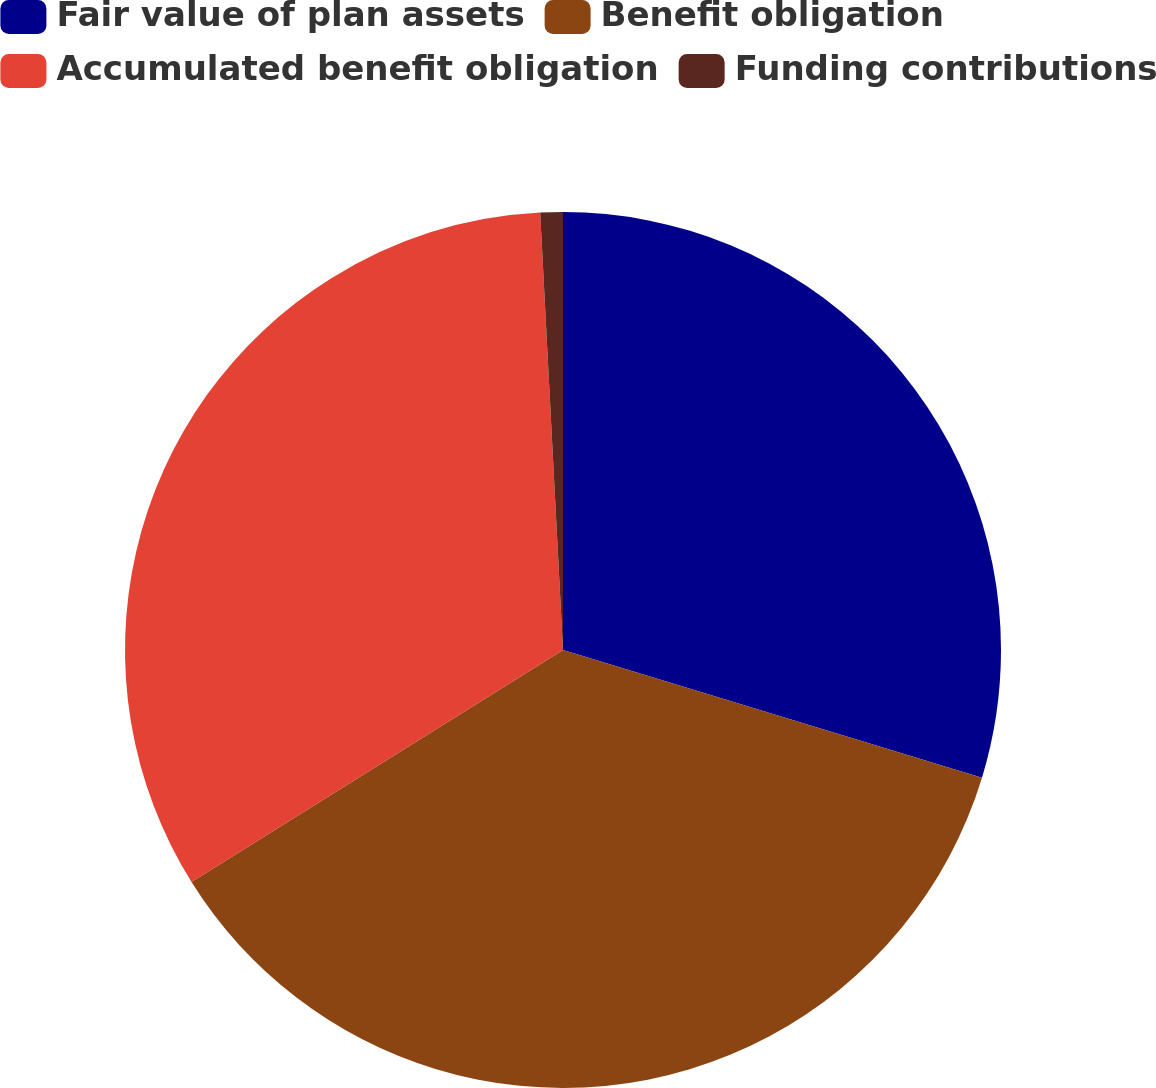<chart> <loc_0><loc_0><loc_500><loc_500><pie_chart><fcel>Fair value of plan assets<fcel>Benefit obligation<fcel>Accumulated benefit obligation<fcel>Funding contributions<nl><fcel>29.71%<fcel>36.41%<fcel>33.06%<fcel>0.83%<nl></chart> 